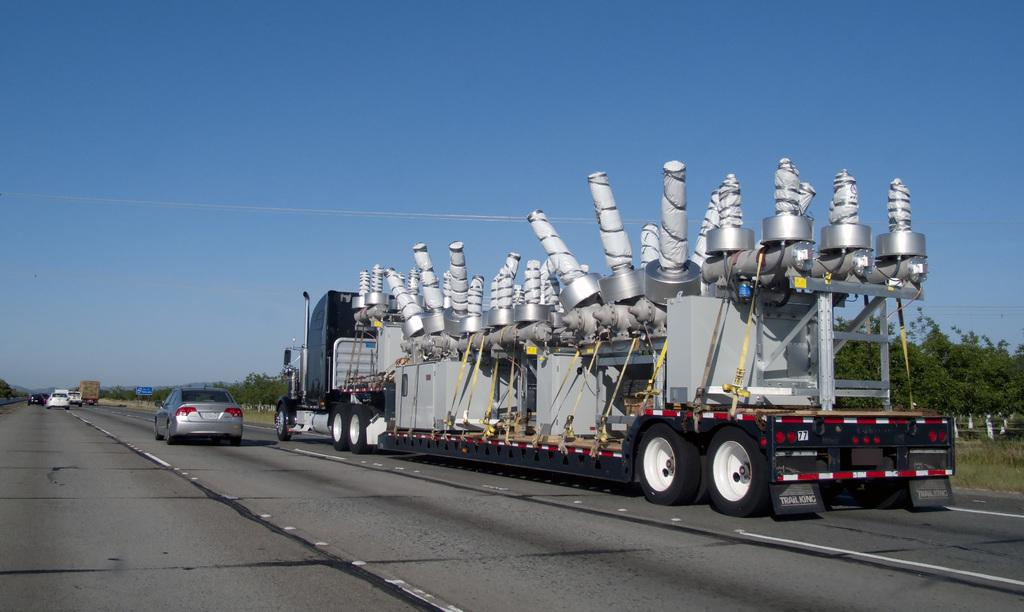What is happening on the road in the image? There is a vehicle moving on the road in the image. What other vehicles can be seen on the road? There are cars on the road in the image. What can be seen in the background of the image? There are trees and the sky visible in the background of the image. Can you tell me how many geese are flying in the image? There are no geese present in the image; it features a vehicle moving on the road with cars and a background of trees and the sky. What type of chess piece is located on the road in the image? There is no chess piece present in the image; it features a vehicle moving on the road with cars and a background of trees and the sky. 